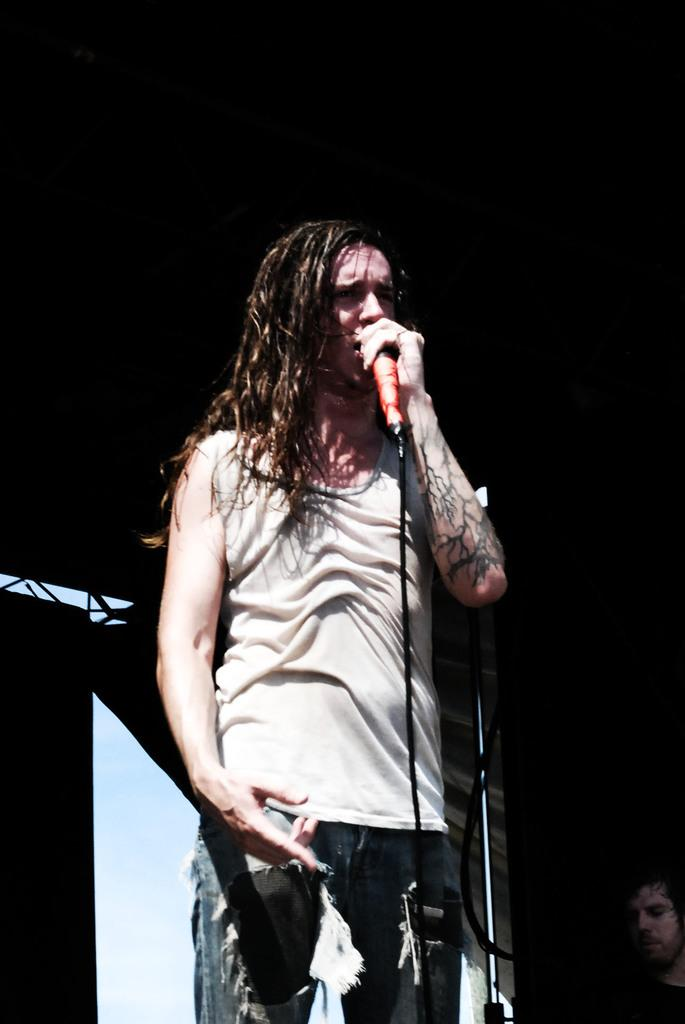What is the main subject of the image? There is a beautiful girl in the image. What is the girl doing in the image? The girl is standing and singing. What type of clothing is the girl wearing on her upper body? The girl is wearing a t-shirt. What type of clothing is the girl wearing on her lower body? The girl is wearing trousers. What type of property does the girl own in the image? There is no information about the girl owning any property in the image. Can you hear the girl whistling in the image? The image is a still image, so there is no sound, and therefore no whistling can be heard. 